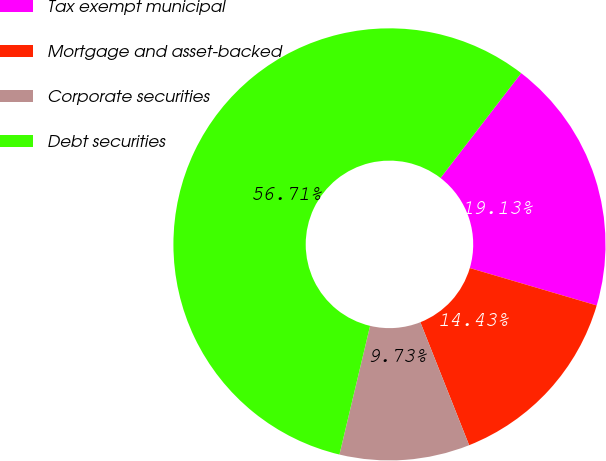Convert chart to OTSL. <chart><loc_0><loc_0><loc_500><loc_500><pie_chart><fcel>Tax exempt municipal<fcel>Mortgage and asset-backed<fcel>Corporate securities<fcel>Debt securities<nl><fcel>19.13%<fcel>14.43%<fcel>9.73%<fcel>56.72%<nl></chart> 